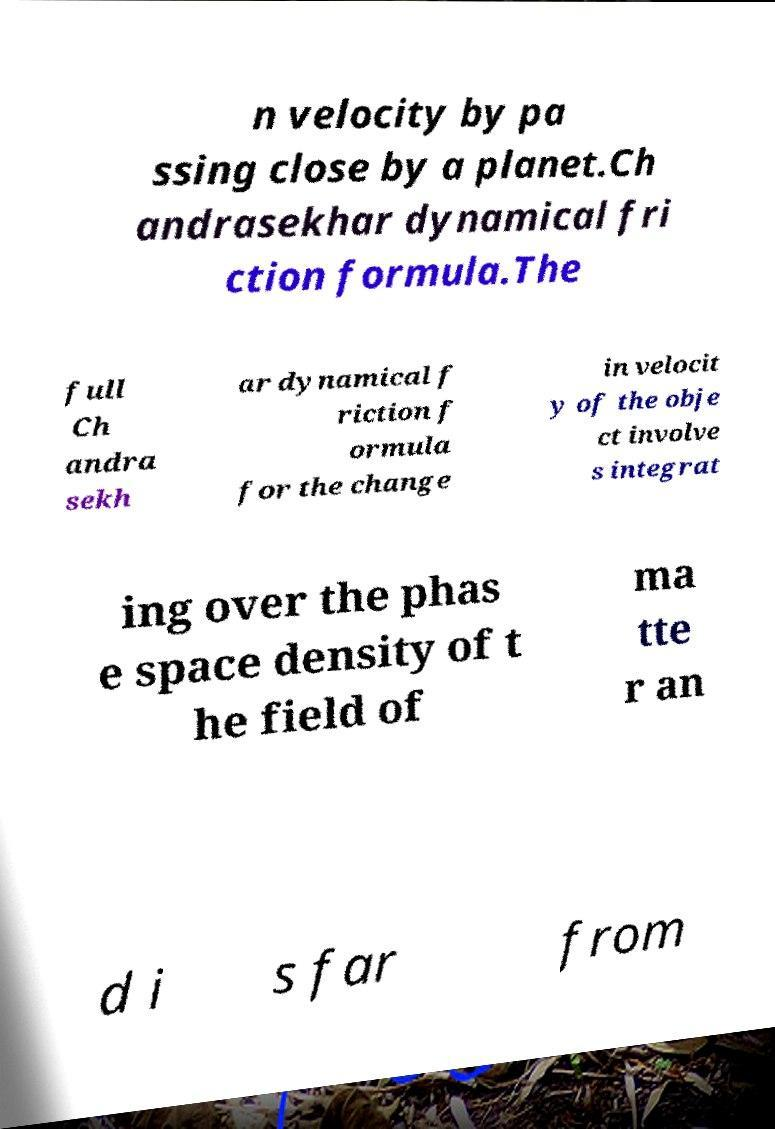Could you extract and type out the text from this image? n velocity by pa ssing close by a planet.Ch andrasekhar dynamical fri ction formula.The full Ch andra sekh ar dynamical f riction f ormula for the change in velocit y of the obje ct involve s integrat ing over the phas e space density of t he field of ma tte r an d i s far from 